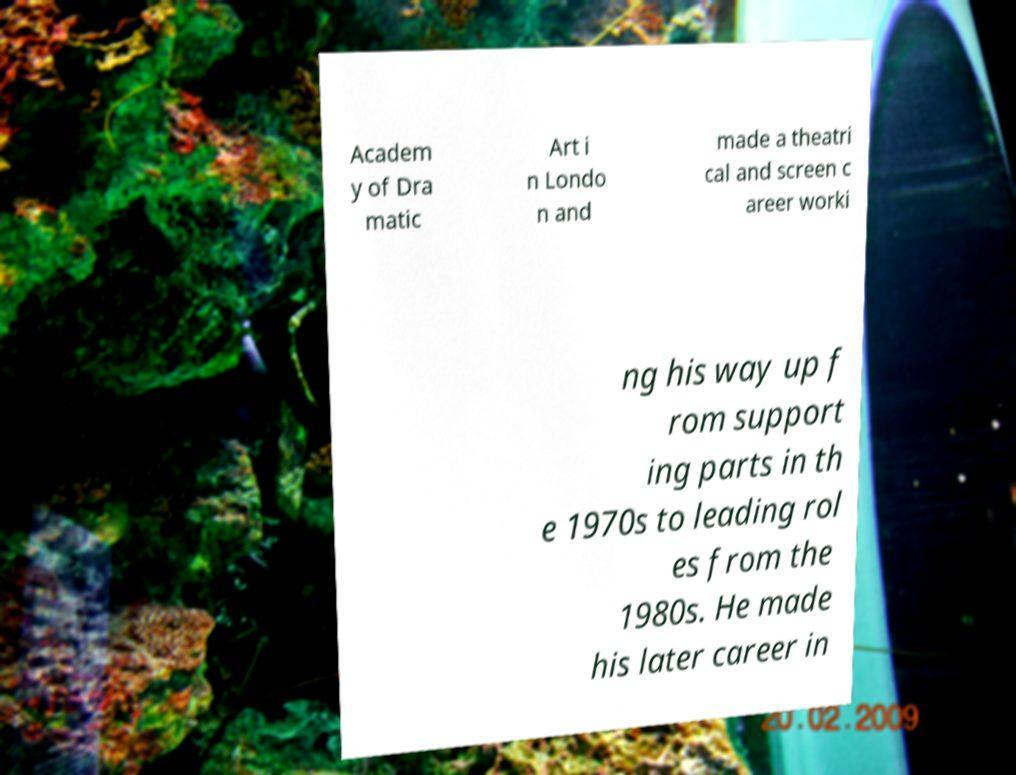Can you read and provide the text displayed in the image?This photo seems to have some interesting text. Can you extract and type it out for me? Academ y of Dra matic Art i n Londo n and made a theatri cal and screen c areer worki ng his way up f rom support ing parts in th e 1970s to leading rol es from the 1980s. He made his later career in 